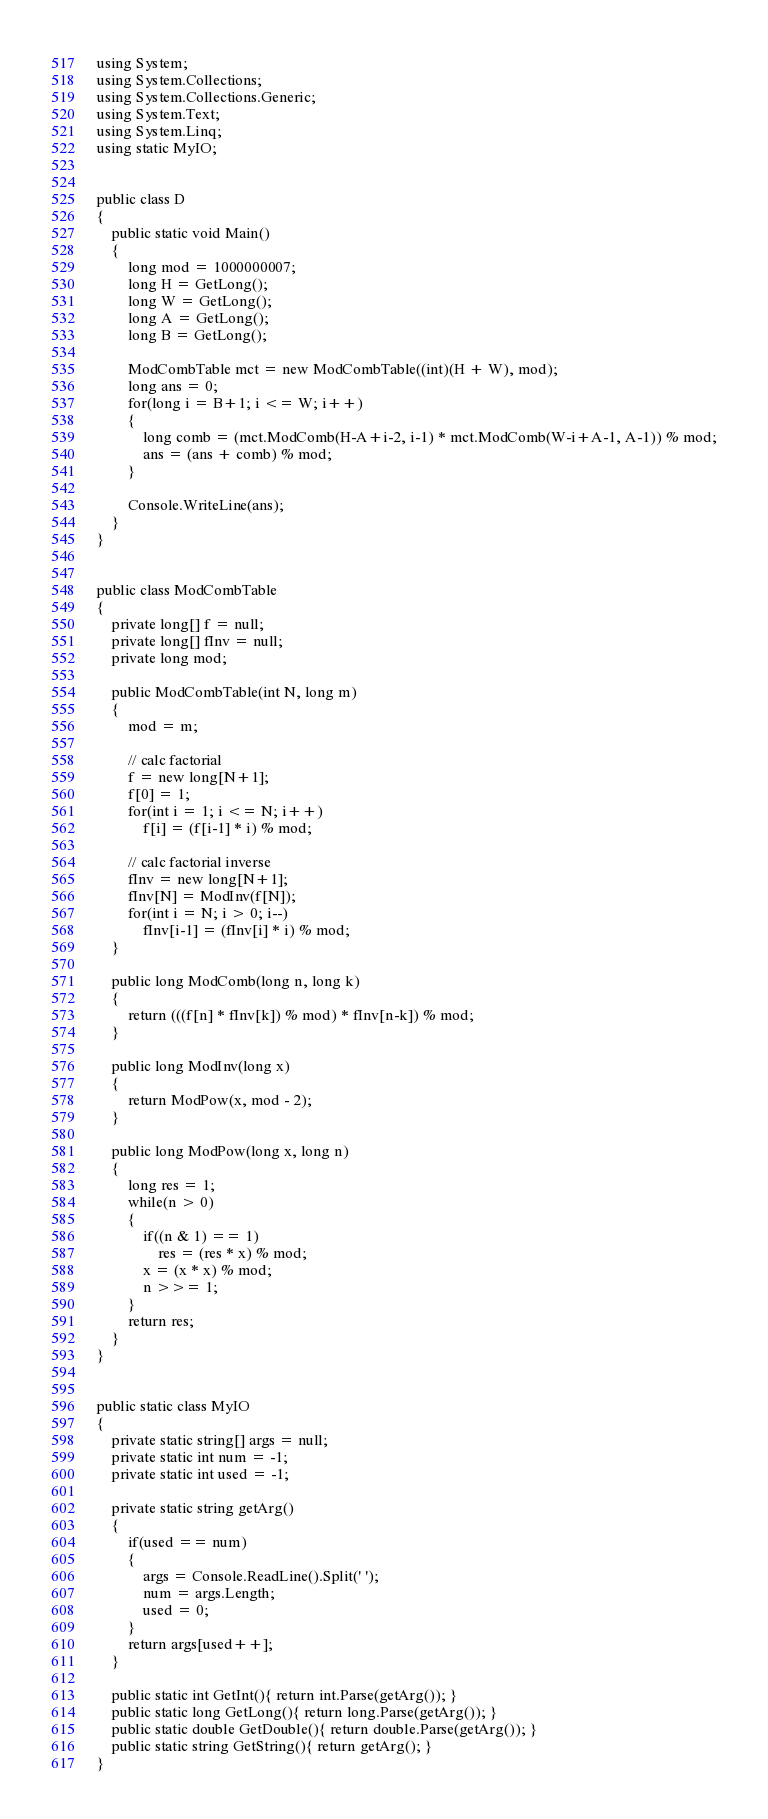Convert code to text. <code><loc_0><loc_0><loc_500><loc_500><_C#_>using System;
using System.Collections;
using System.Collections.Generic;
using System.Text;
using System.Linq;
using static MyIO;


public class D
{
	public static void Main()
	{
		long mod = 1000000007;
		long H = GetLong();
		long W = GetLong();
		long A = GetLong();
		long B = GetLong();

		ModCombTable mct = new ModCombTable((int)(H + W), mod);
		long ans = 0;
		for(long i = B+1; i <= W; i++)
		{
			long comb = (mct.ModComb(H-A+i-2, i-1) * mct.ModComb(W-i+A-1, A-1)) % mod;
			ans = (ans + comb) % mod;
		}

		Console.WriteLine(ans);
	}
}


public class ModCombTable
{
	private long[] f = null;
	private long[] fInv = null;
	private long mod;

	public ModCombTable(int N, long m)
	{
		mod = m;

		// calc factorial
		f = new long[N+1];
		f[0] = 1;
		for(int i = 1; i <= N; i++)
			f[i] = (f[i-1] * i) % mod;

		// calc factorial inverse
		fInv = new long[N+1];
		fInv[N] = ModInv(f[N]);
		for(int i = N; i > 0; i--)
			fInv[i-1] = (fInv[i] * i) % mod;
	}

	public long ModComb(long n, long k)
	{
		return (((f[n] * fInv[k]) % mod) * fInv[n-k]) % mod;
	}

	public long ModInv(long x)
	{
		return ModPow(x, mod - 2);
	}

	public long ModPow(long x, long n)
	{
		long res = 1;
		while(n > 0)
		{
			if((n & 1) == 1)
				res = (res * x) % mod;
			x = (x * x) % mod;
			n >>= 1;
		}
		return res;
	}
}


public static class MyIO
{
	private static string[] args = null;
	private static int num = -1;
	private static int used = -1;

	private static string getArg()
	{
		if(used == num)
		{
			args = Console.ReadLine().Split(' ');
			num = args.Length;
			used = 0;
		}
		return args[used++];
	}

	public static int GetInt(){ return int.Parse(getArg()); }
	public static long GetLong(){ return long.Parse(getArg()); }
	public static double GetDouble(){ return double.Parse(getArg()); }
	public static string GetString(){ return getArg(); }
}</code> 